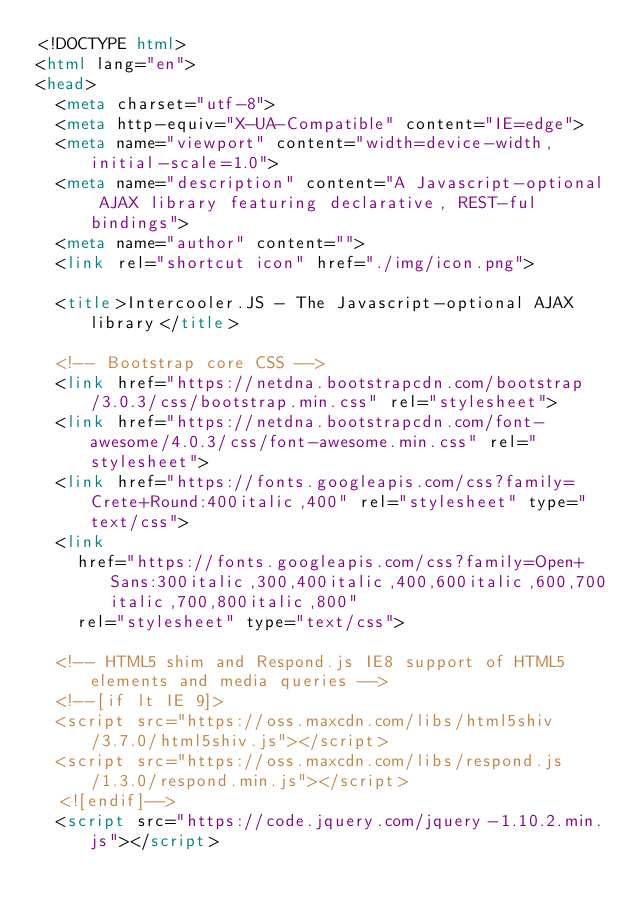Convert code to text. <code><loc_0><loc_0><loc_500><loc_500><_HTML_><!DOCTYPE html>
<html lang="en">
<head>
  <meta charset="utf-8">
  <meta http-equiv="X-UA-Compatible" content="IE=edge">
  <meta name="viewport" content="width=device-width, initial-scale=1.0">
  <meta name="description" content="A Javascript-optional AJAX library featuring declarative, REST-ful bindings">
  <meta name="author" content="">
  <link rel="shortcut icon" href="./img/icon.png">

  <title>Intercooler.JS - The Javascript-optional AJAX library</title>

  <!-- Bootstrap core CSS -->
  <link href="https://netdna.bootstrapcdn.com/bootstrap/3.0.3/css/bootstrap.min.css" rel="stylesheet">
  <link href="https://netdna.bootstrapcdn.com/font-awesome/4.0.3/css/font-awesome.min.css" rel="stylesheet">
  <link href="https://fonts.googleapis.com/css?family=Crete+Round:400italic,400" rel="stylesheet" type="text/css">
  <link
    href="https://fonts.googleapis.com/css?family=Open+Sans:300italic,300,400italic,400,600italic,600,700italic,700,800italic,800"
    rel="stylesheet" type="text/css">

  <!-- HTML5 shim and Respond.js IE8 support of HTML5 elements and media queries -->
  <!--[if lt IE 9]>
  <script src="https://oss.maxcdn.com/libs/html5shiv/3.7.0/html5shiv.js"></script>
  <script src="https://oss.maxcdn.com/libs/respond.js/1.3.0/respond.min.js"></script>
  <![endif]-->
  <script src="https://code.jquery.com/jquery-1.10.2.min.js"></script></code> 